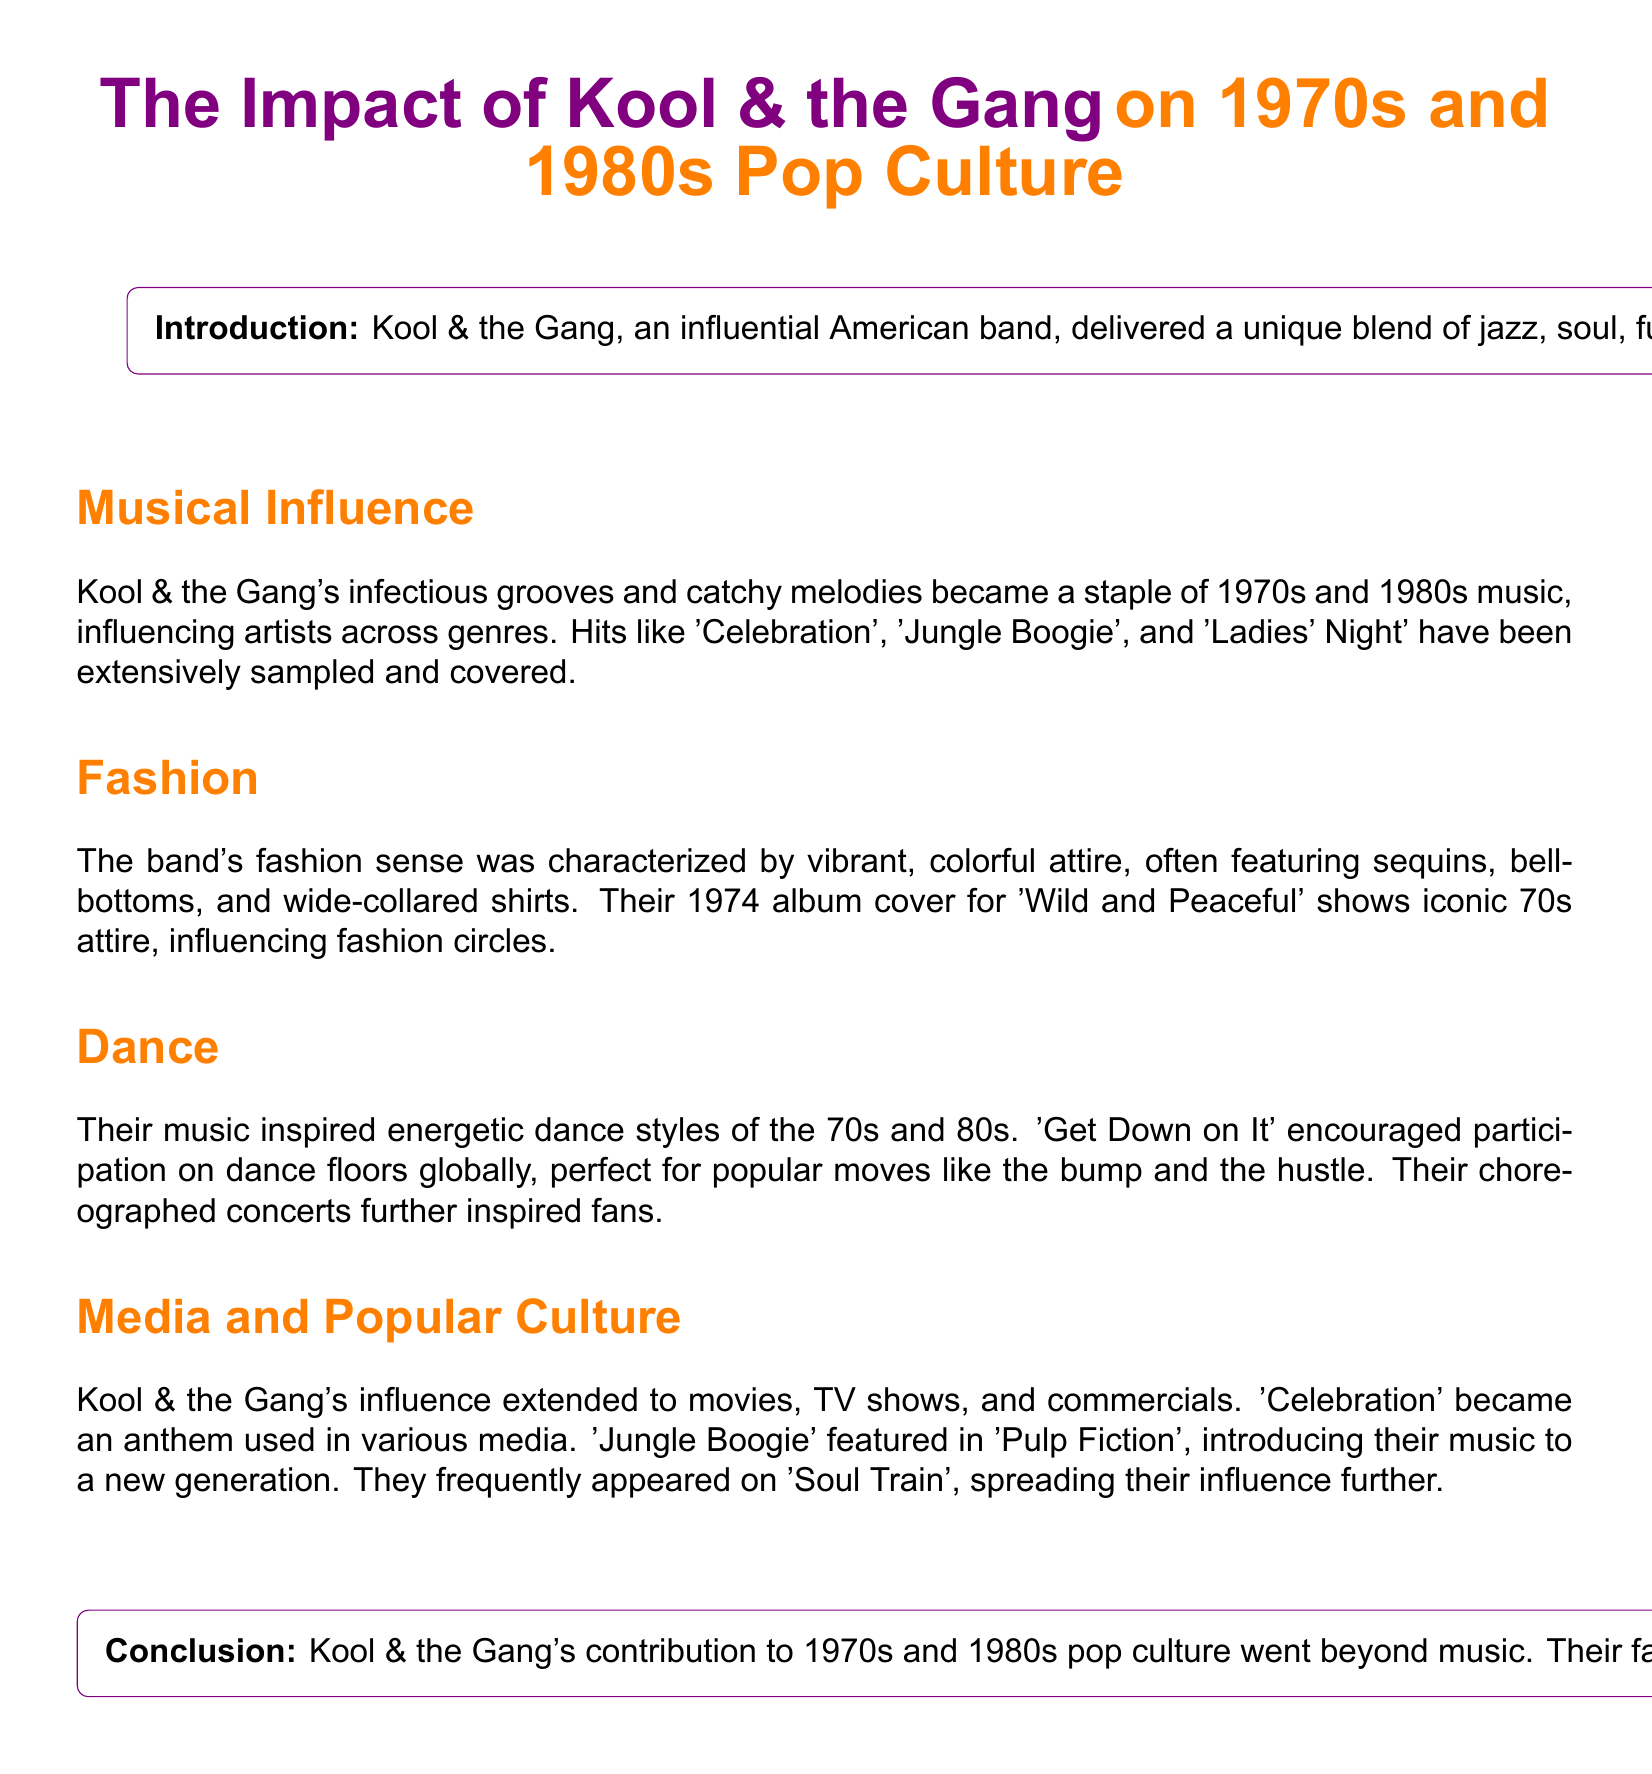What was the genre blend of Kool & the Gang's music? The document states that Kool & the Gang delivered a unique blend of jazz, soul, funk, and R&B.
Answer: jazz, soul, funk, R&B Which song became an anthem used in various media? The document mentions that 'Celebration' became an anthem used in various media.
Answer: Celebration What year was the album 'Wild and Peaceful' released? The document does not state a specific year but mentions the album cover from 1974.
Answer: 1974 Which dance style did 'Get Down on It' inspire? The document notes that 'Get Down on It' encouraged participation in energetic dance styles.
Answer: energetic dance styles What movie featured the song 'Jungle Boogie'? The document clearly states that 'Jungle Boogie' featured in 'Pulp Fiction'.
Answer: Pulp Fiction What clothing style was associated with Kool & the Gang? The document describes the band's fashion style as characterized by vibrant, colorful attire.
Answer: vibrant, colorful attire How did Kool & the Gang influence the fashion of the 70s? According to the text, their fashion sense included sequins, bell-bottoms, and wide-collared shirts, influencing fashion circles.
Answer: sequins, bell-bottoms, wide-collared shirts In what decade did Kool & the Gang peak? The document describes their impact on pop culture during the 1970s and 1980s.
Answer: 1970s and 1980s What was a notable feature of their concerts? The document states that their choreographed concerts further inspired fans.
Answer: choreographed concerts 